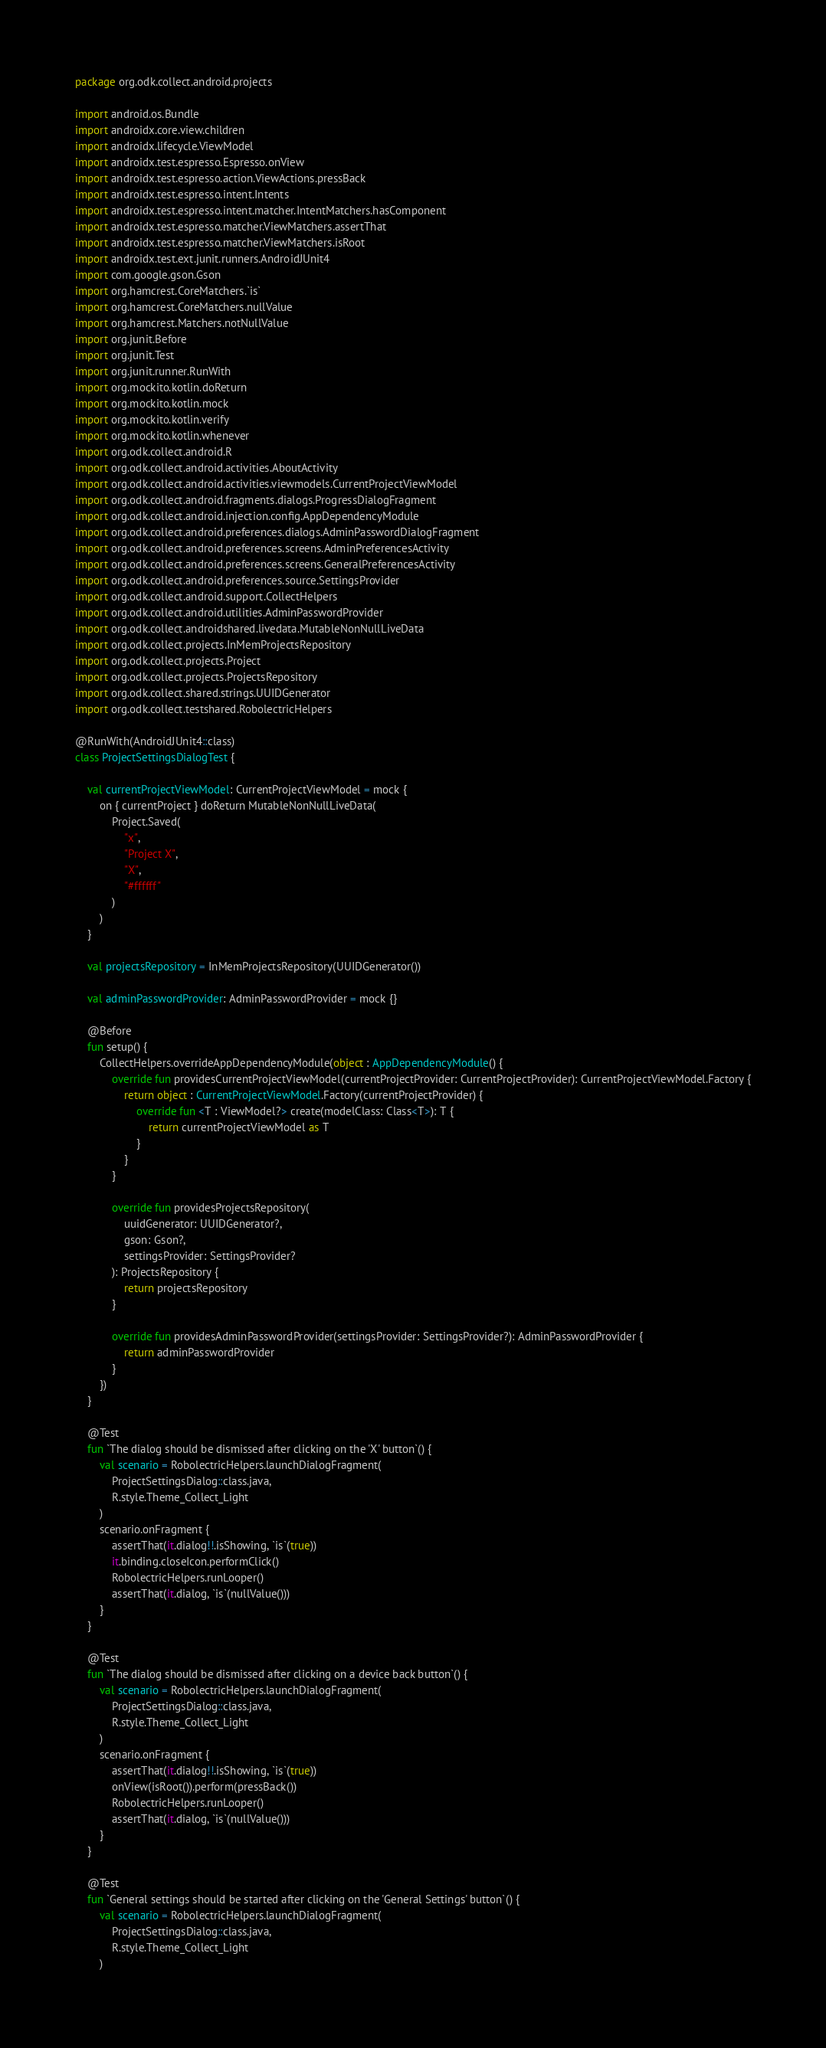Convert code to text. <code><loc_0><loc_0><loc_500><loc_500><_Kotlin_>package org.odk.collect.android.projects

import android.os.Bundle
import androidx.core.view.children
import androidx.lifecycle.ViewModel
import androidx.test.espresso.Espresso.onView
import androidx.test.espresso.action.ViewActions.pressBack
import androidx.test.espresso.intent.Intents
import androidx.test.espresso.intent.matcher.IntentMatchers.hasComponent
import androidx.test.espresso.matcher.ViewMatchers.assertThat
import androidx.test.espresso.matcher.ViewMatchers.isRoot
import androidx.test.ext.junit.runners.AndroidJUnit4
import com.google.gson.Gson
import org.hamcrest.CoreMatchers.`is`
import org.hamcrest.CoreMatchers.nullValue
import org.hamcrest.Matchers.notNullValue
import org.junit.Before
import org.junit.Test
import org.junit.runner.RunWith
import org.mockito.kotlin.doReturn
import org.mockito.kotlin.mock
import org.mockito.kotlin.verify
import org.mockito.kotlin.whenever
import org.odk.collect.android.R
import org.odk.collect.android.activities.AboutActivity
import org.odk.collect.android.activities.viewmodels.CurrentProjectViewModel
import org.odk.collect.android.fragments.dialogs.ProgressDialogFragment
import org.odk.collect.android.injection.config.AppDependencyModule
import org.odk.collect.android.preferences.dialogs.AdminPasswordDialogFragment
import org.odk.collect.android.preferences.screens.AdminPreferencesActivity
import org.odk.collect.android.preferences.screens.GeneralPreferencesActivity
import org.odk.collect.android.preferences.source.SettingsProvider
import org.odk.collect.android.support.CollectHelpers
import org.odk.collect.android.utilities.AdminPasswordProvider
import org.odk.collect.androidshared.livedata.MutableNonNullLiveData
import org.odk.collect.projects.InMemProjectsRepository
import org.odk.collect.projects.Project
import org.odk.collect.projects.ProjectsRepository
import org.odk.collect.shared.strings.UUIDGenerator
import org.odk.collect.testshared.RobolectricHelpers

@RunWith(AndroidJUnit4::class)
class ProjectSettingsDialogTest {

    val currentProjectViewModel: CurrentProjectViewModel = mock {
        on { currentProject } doReturn MutableNonNullLiveData(
            Project.Saved(
                "x",
                "Project X",
                "X",
                "#ffffff"
            )
        )
    }

    val projectsRepository = InMemProjectsRepository(UUIDGenerator())

    val adminPasswordProvider: AdminPasswordProvider = mock {}

    @Before
    fun setup() {
        CollectHelpers.overrideAppDependencyModule(object : AppDependencyModule() {
            override fun providesCurrentProjectViewModel(currentProjectProvider: CurrentProjectProvider): CurrentProjectViewModel.Factory {
                return object : CurrentProjectViewModel.Factory(currentProjectProvider) {
                    override fun <T : ViewModel?> create(modelClass: Class<T>): T {
                        return currentProjectViewModel as T
                    }
                }
            }

            override fun providesProjectsRepository(
                uuidGenerator: UUIDGenerator?,
                gson: Gson?,
                settingsProvider: SettingsProvider?
            ): ProjectsRepository {
                return projectsRepository
            }

            override fun providesAdminPasswordProvider(settingsProvider: SettingsProvider?): AdminPasswordProvider {
                return adminPasswordProvider
            }
        })
    }

    @Test
    fun `The dialog should be dismissed after clicking on the 'X' button`() {
        val scenario = RobolectricHelpers.launchDialogFragment(
            ProjectSettingsDialog::class.java,
            R.style.Theme_Collect_Light
        )
        scenario.onFragment {
            assertThat(it.dialog!!.isShowing, `is`(true))
            it.binding.closeIcon.performClick()
            RobolectricHelpers.runLooper()
            assertThat(it.dialog, `is`(nullValue()))
        }
    }

    @Test
    fun `The dialog should be dismissed after clicking on a device back button`() {
        val scenario = RobolectricHelpers.launchDialogFragment(
            ProjectSettingsDialog::class.java,
            R.style.Theme_Collect_Light
        )
        scenario.onFragment {
            assertThat(it.dialog!!.isShowing, `is`(true))
            onView(isRoot()).perform(pressBack())
            RobolectricHelpers.runLooper()
            assertThat(it.dialog, `is`(nullValue()))
        }
    }

    @Test
    fun `General settings should be started after clicking on the 'General Settings' button`() {
        val scenario = RobolectricHelpers.launchDialogFragment(
            ProjectSettingsDialog::class.java,
            R.style.Theme_Collect_Light
        )</code> 